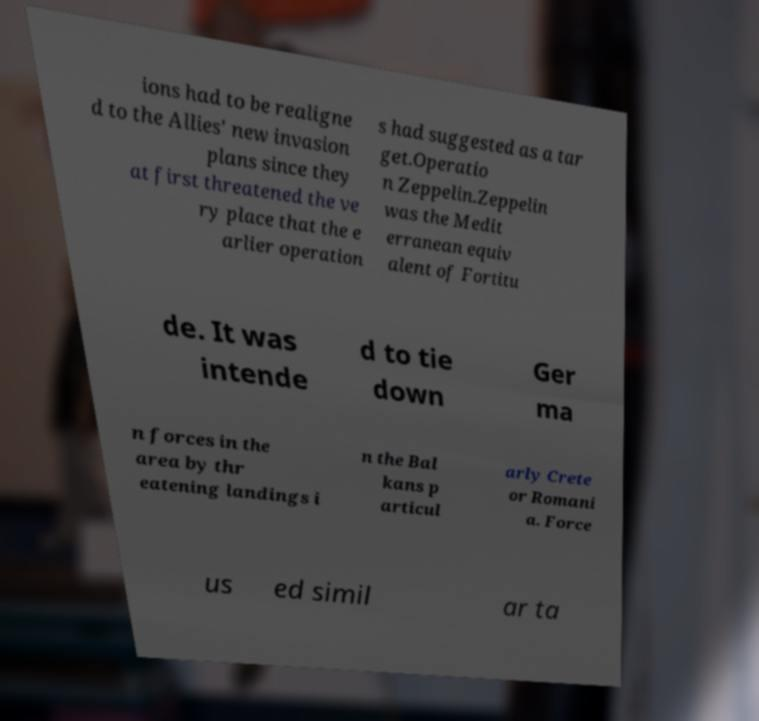I need the written content from this picture converted into text. Can you do that? ions had to be realigne d to the Allies' new invasion plans since they at first threatened the ve ry place that the e arlier operation s had suggested as a tar get.Operatio n Zeppelin.Zeppelin was the Medit erranean equiv alent of Fortitu de. It was intende d to tie down Ger ma n forces in the area by thr eatening landings i n the Bal kans p articul arly Crete or Romani a. Force us ed simil ar ta 